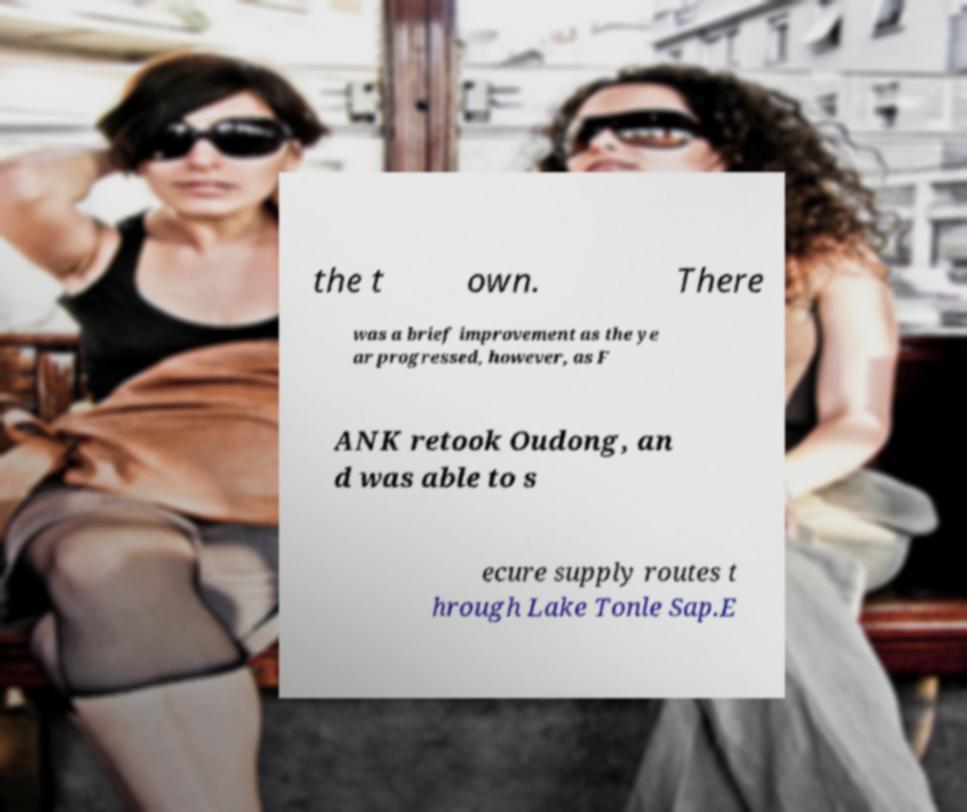Could you extract and type out the text from this image? the t own. There was a brief improvement as the ye ar progressed, however, as F ANK retook Oudong, an d was able to s ecure supply routes t hrough Lake Tonle Sap.E 